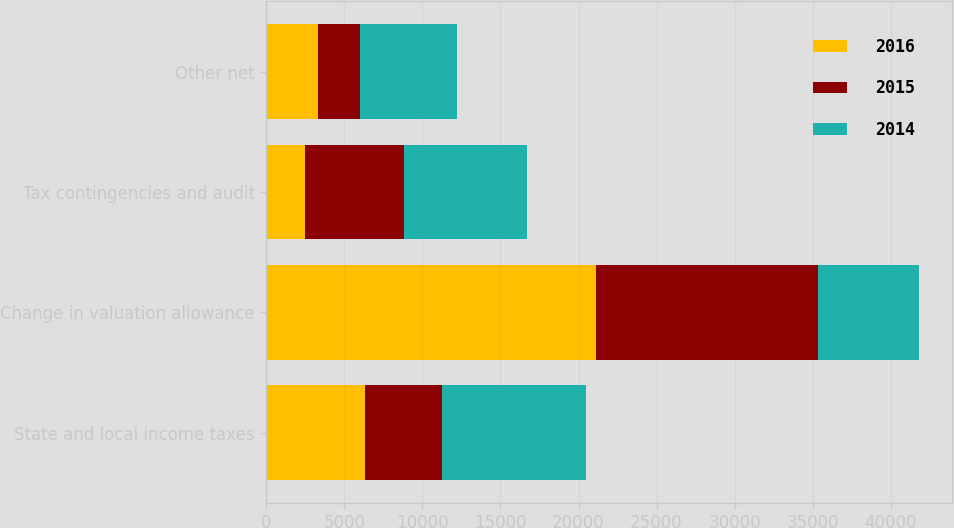<chart> <loc_0><loc_0><loc_500><loc_500><stacked_bar_chart><ecel><fcel>State and local income taxes<fcel>Change in valuation allowance<fcel>Tax contingencies and audit<fcel>Other net<nl><fcel>2016<fcel>6298<fcel>21106<fcel>2496<fcel>3306<nl><fcel>2015<fcel>4951<fcel>14237<fcel>6298<fcel>2711<nl><fcel>2014<fcel>9239<fcel>6482<fcel>7882<fcel>6215<nl></chart> 